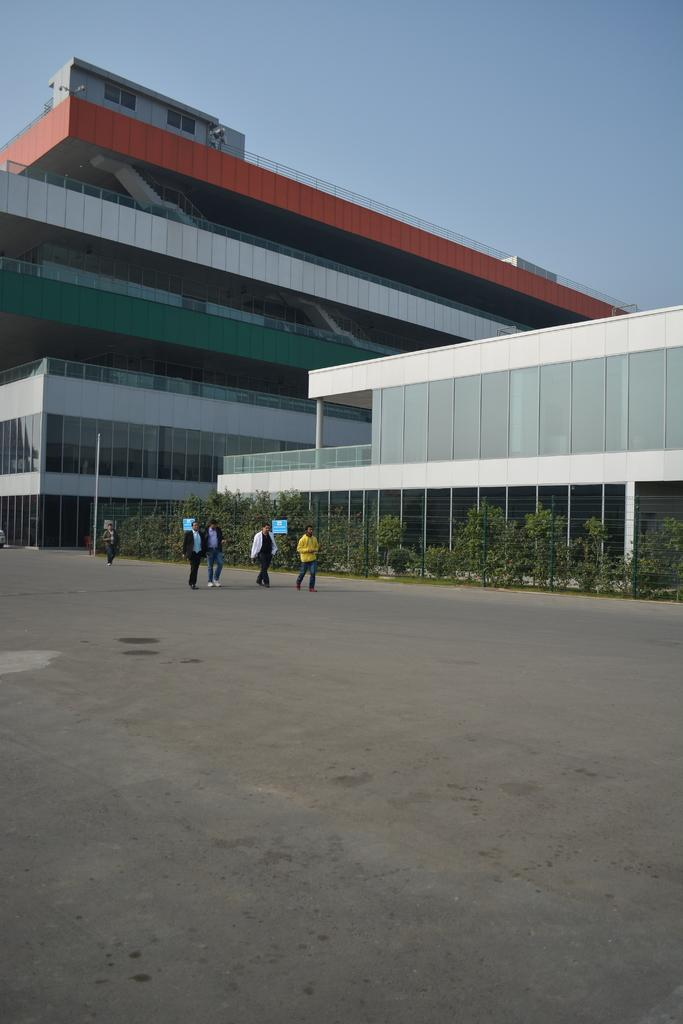What are the people in the image doing? The persons in the image are standing on the road. What can be seen beside the persons? There are plants beside the persons. What can be seen in the background of the image? There are two buildings in the background. What type of stage can be seen in the image? There is no stage present in the image. What kind of attraction is visible in the image? There is no attraction visible in the image. 